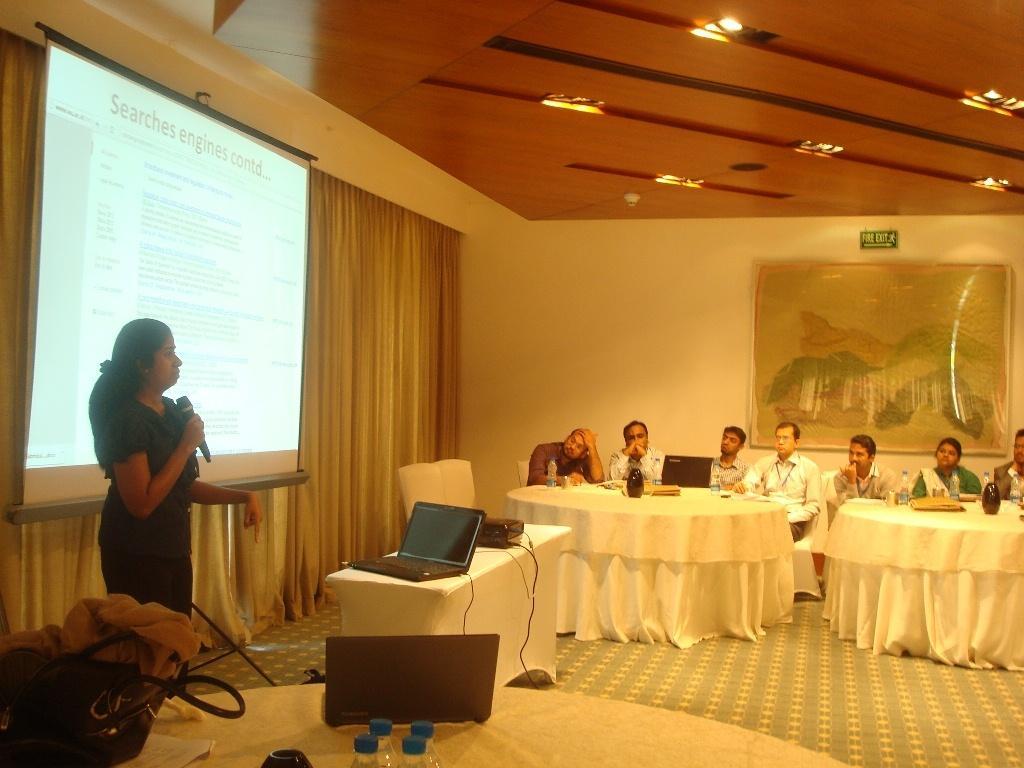Could you give a brief overview of what you see in this image? In this picture we can see a group of people on the ground, they are sitting on chairs, one woman is standing and holding a mic, here we can see tables, laptops, bag, clothes, bottles and some objects and in the background we can see a wall, photo frame, sign board, roof, lights, projector screen, curtain. 